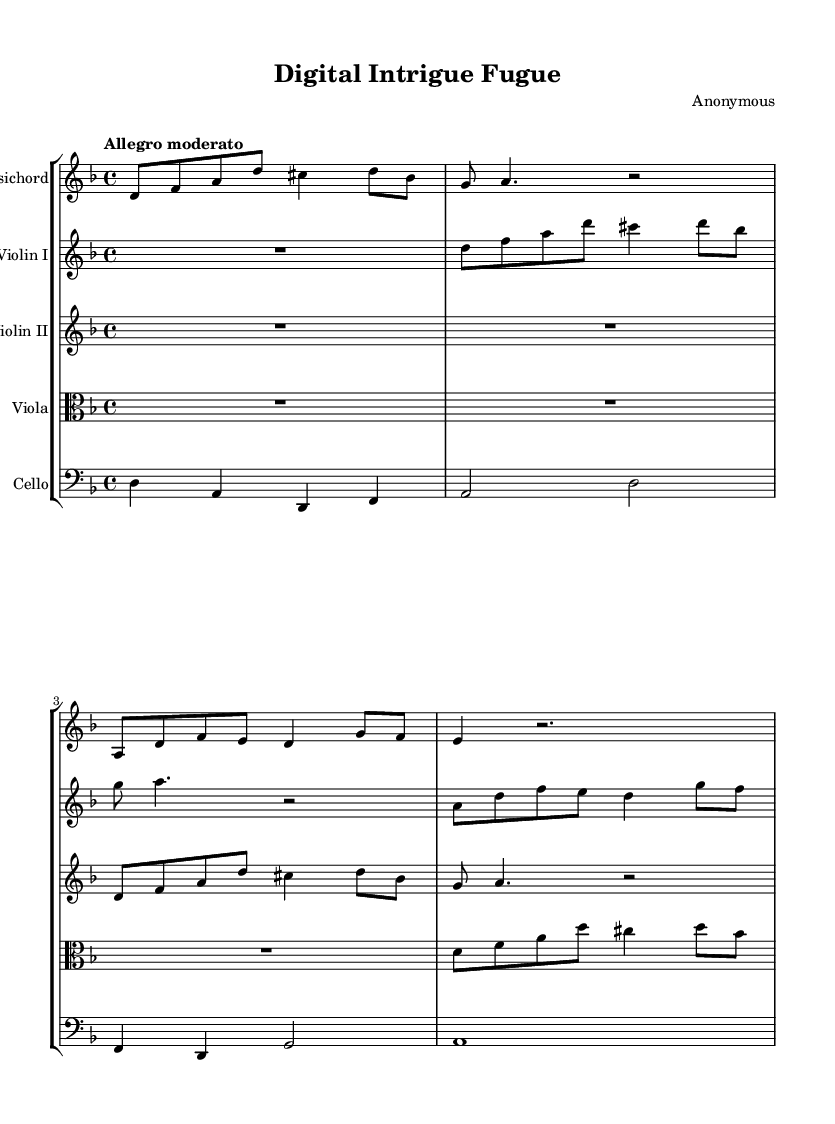What is the key signature of this music? The key signature is indicated at the beginning of the score, where there are two flats, indicating the piece is in D minor (which has one flat as its relative major, F major).
Answer: D minor What is the time signature of this music? The time signature appears at the start of the score, where it shows "4/4," indicating there are four beats in each measure and a quarter note gets one beat.
Answer: 4/4 What is the tempo marking for this piece? The tempo is stated directly above the staff at the beginning of the music as "Allegro moderato," which indicates a moderate speed, generally faster than moderate but not too fast.
Answer: Allegro moderato In which instruments is this composition written? The composition lists its instrumentation at the beginning, which includes Harpsichord, Violin I, Violin II, Viola, and Cello, representing a typical Baroque ensemble.
Answer: Harpsichord, Violin I, Violin II, Viola, Cello How many measures are in the score? By counting the groups of notes and the endings represented, there are a total of 8 measures visible in each of the parts as presented in the excerpt.
Answer: 8 What thematic concept is explored by this piece? The title "Digital Intrigue Fugue" suggests exploration of secrecy and hidden information, common themes in Baroque music often representative of intricate counterpoint and complex relationships.
Answer: Secrecy Which musical form is employed in this composition? The structure indicated by the title and the multi-voiced interplay suggests this piece is in a Fugue format, where themes and motifs are developed and interwoven throughout the composition.
Answer: Fugue 